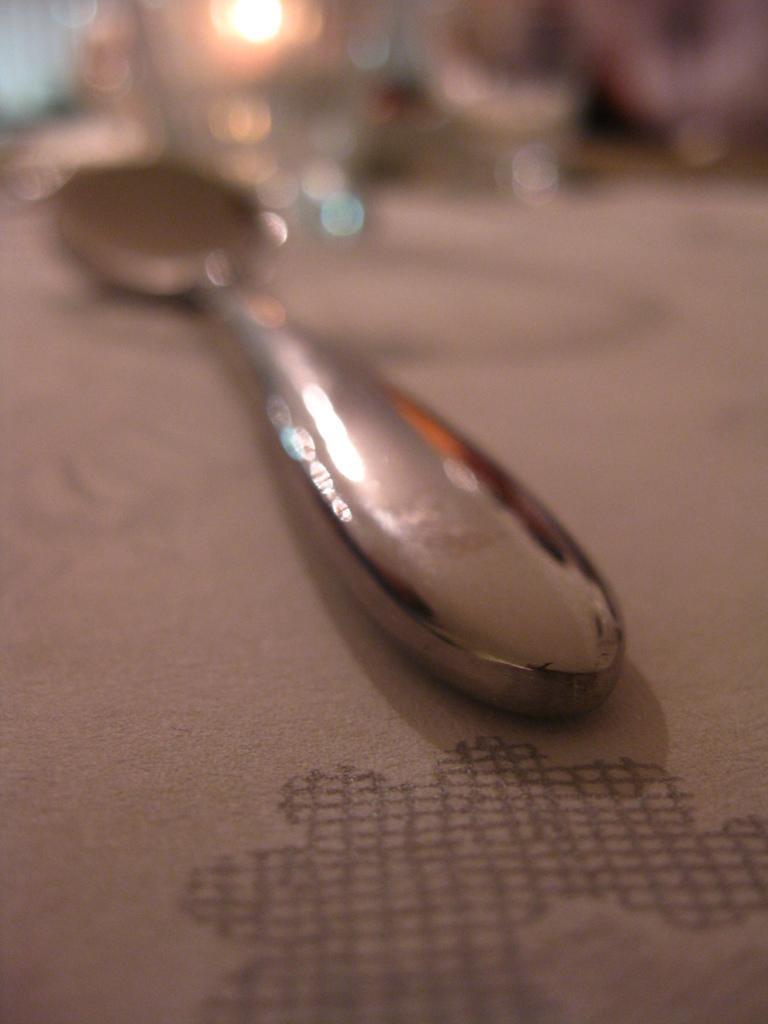What is covering the table in the image? There is a table covered with cloth in the image. What object can be seen in the center of the image? There is a spoon in the center of the image. What might the blurred objects at the top of the image be? The blurred objects at the top of the image might be glass-like objects. Can you describe the lighting in the image? There is light visible in the image. What type of knowledge does the doctor share in the image? There is no doctor present in the image, so no knowledge can be shared. What type of fiction is depicted in the image? There is no fiction depicted in the image; it features a table, cloth, spoon, and blurred objects. 